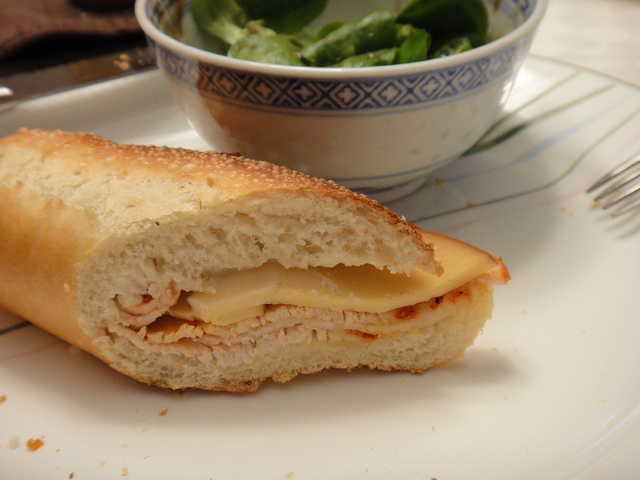<image>What type of fruit is by the sandwich? I am not sure what type of fruit is by the sandwich. It is possible that there's no fruit or it's a kiwi. What type of fruit is by the sandwich? I am not sure what type of fruit is by the sandwich. It can be either kiwi or apple, or there may be no fruit at all. 